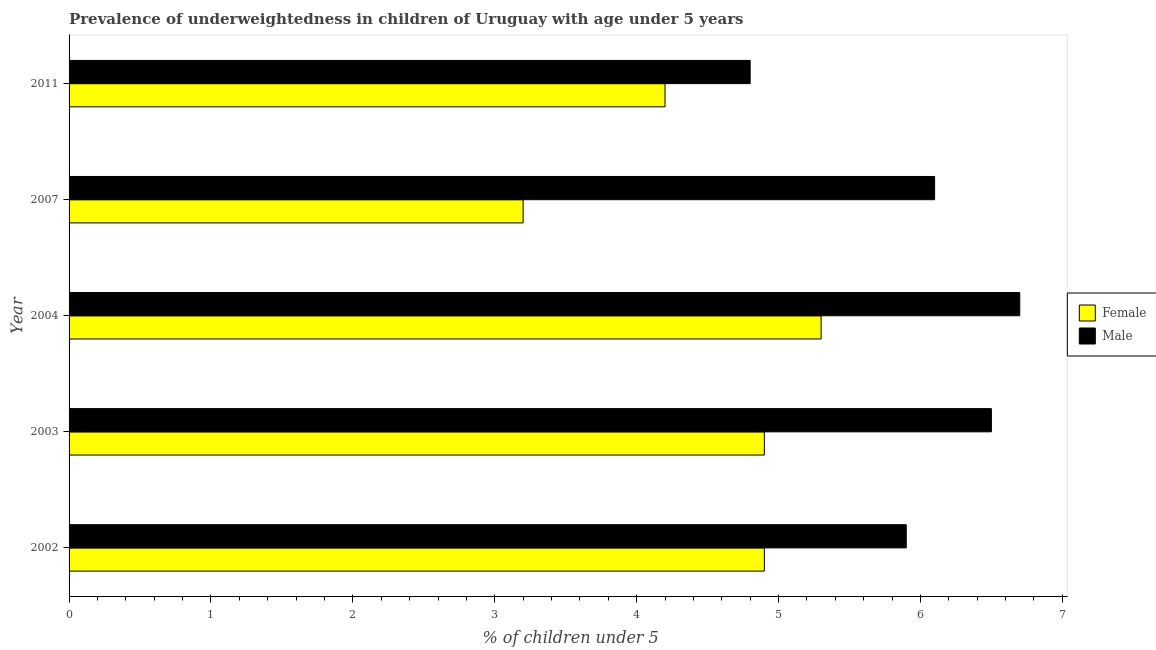How many bars are there on the 2nd tick from the bottom?
Provide a succinct answer. 2. What is the label of the 3rd group of bars from the top?
Give a very brief answer. 2004. In how many cases, is the number of bars for a given year not equal to the number of legend labels?
Your answer should be compact. 0. What is the percentage of underweighted female children in 2011?
Your answer should be compact. 4.2. Across all years, what is the maximum percentage of underweighted female children?
Offer a very short reply. 5.3. Across all years, what is the minimum percentage of underweighted female children?
Your answer should be compact. 3.2. In which year was the percentage of underweighted female children maximum?
Provide a short and direct response. 2004. What is the total percentage of underweighted male children in the graph?
Offer a terse response. 30. What is the difference between the percentage of underweighted female children in 2002 and the percentage of underweighted male children in 2004?
Give a very brief answer. -1.8. In how many years, is the percentage of underweighted male children greater than 6.8 %?
Offer a terse response. 0. Is the percentage of underweighted female children in 2002 less than that in 2007?
Make the answer very short. No. Is the difference between the percentage of underweighted male children in 2003 and 2004 greater than the difference between the percentage of underweighted female children in 2003 and 2004?
Provide a short and direct response. Yes. In how many years, is the percentage of underweighted female children greater than the average percentage of underweighted female children taken over all years?
Give a very brief answer. 3. What does the 1st bar from the bottom in 2002 represents?
Give a very brief answer. Female. How many years are there in the graph?
Keep it short and to the point. 5. Does the graph contain grids?
Your answer should be compact. No. Where does the legend appear in the graph?
Provide a succinct answer. Center right. What is the title of the graph?
Provide a short and direct response. Prevalence of underweightedness in children of Uruguay with age under 5 years. Does "Electricity and heat production" appear as one of the legend labels in the graph?
Make the answer very short. No. What is the label or title of the X-axis?
Give a very brief answer.  % of children under 5. What is the  % of children under 5 in Female in 2002?
Offer a terse response. 4.9. What is the  % of children under 5 in Male in 2002?
Keep it short and to the point. 5.9. What is the  % of children under 5 in Female in 2003?
Your response must be concise. 4.9. What is the  % of children under 5 of Male in 2003?
Offer a terse response. 6.5. What is the  % of children under 5 in Female in 2004?
Make the answer very short. 5.3. What is the  % of children under 5 of Male in 2004?
Provide a succinct answer. 6.7. What is the  % of children under 5 of Female in 2007?
Provide a succinct answer. 3.2. What is the  % of children under 5 of Male in 2007?
Offer a terse response. 6.1. What is the  % of children under 5 of Female in 2011?
Make the answer very short. 4.2. What is the  % of children under 5 of Male in 2011?
Offer a very short reply. 4.8. Across all years, what is the maximum  % of children under 5 of Female?
Offer a very short reply. 5.3. Across all years, what is the maximum  % of children under 5 in Male?
Provide a succinct answer. 6.7. Across all years, what is the minimum  % of children under 5 of Female?
Provide a short and direct response. 3.2. Across all years, what is the minimum  % of children under 5 in Male?
Make the answer very short. 4.8. What is the total  % of children under 5 of Female in the graph?
Keep it short and to the point. 22.5. What is the total  % of children under 5 of Male in the graph?
Your answer should be compact. 30. What is the difference between the  % of children under 5 of Female in 2002 and that in 2004?
Provide a succinct answer. -0.4. What is the difference between the  % of children under 5 in Male in 2002 and that in 2004?
Ensure brevity in your answer.  -0.8. What is the difference between the  % of children under 5 in Male in 2002 and that in 2007?
Your answer should be very brief. -0.2. What is the difference between the  % of children under 5 in Female in 2003 and that in 2007?
Your response must be concise. 1.7. What is the difference between the  % of children under 5 in Female in 2004 and that in 2007?
Provide a succinct answer. 2.1. What is the difference between the  % of children under 5 of Male in 2004 and that in 2007?
Provide a succinct answer. 0.6. What is the difference between the  % of children under 5 in Female in 2004 and that in 2011?
Give a very brief answer. 1.1. What is the difference between the  % of children under 5 in Male in 2004 and that in 2011?
Offer a terse response. 1.9. What is the difference between the  % of children under 5 of Male in 2007 and that in 2011?
Provide a short and direct response. 1.3. What is the difference between the  % of children under 5 of Female in 2002 and the  % of children under 5 of Male in 2011?
Provide a short and direct response. 0.1. What is the difference between the  % of children under 5 in Female in 2003 and the  % of children under 5 in Male in 2004?
Your answer should be compact. -1.8. What is the difference between the  % of children under 5 in Female in 2003 and the  % of children under 5 in Male in 2007?
Keep it short and to the point. -1.2. What is the difference between the  % of children under 5 of Female in 2003 and the  % of children under 5 of Male in 2011?
Make the answer very short. 0.1. In the year 2002, what is the difference between the  % of children under 5 in Female and  % of children under 5 in Male?
Your response must be concise. -1. In the year 2004, what is the difference between the  % of children under 5 in Female and  % of children under 5 in Male?
Your answer should be compact. -1.4. In the year 2011, what is the difference between the  % of children under 5 in Female and  % of children under 5 in Male?
Your response must be concise. -0.6. What is the ratio of the  % of children under 5 of Male in 2002 to that in 2003?
Your answer should be compact. 0.91. What is the ratio of the  % of children under 5 of Female in 2002 to that in 2004?
Offer a terse response. 0.92. What is the ratio of the  % of children under 5 in Male in 2002 to that in 2004?
Provide a short and direct response. 0.88. What is the ratio of the  % of children under 5 in Female in 2002 to that in 2007?
Your answer should be very brief. 1.53. What is the ratio of the  % of children under 5 in Male in 2002 to that in 2007?
Keep it short and to the point. 0.97. What is the ratio of the  % of children under 5 of Female in 2002 to that in 2011?
Offer a very short reply. 1.17. What is the ratio of the  % of children under 5 of Male in 2002 to that in 2011?
Ensure brevity in your answer.  1.23. What is the ratio of the  % of children under 5 of Female in 2003 to that in 2004?
Make the answer very short. 0.92. What is the ratio of the  % of children under 5 of Male in 2003 to that in 2004?
Provide a short and direct response. 0.97. What is the ratio of the  % of children under 5 of Female in 2003 to that in 2007?
Provide a short and direct response. 1.53. What is the ratio of the  % of children under 5 of Male in 2003 to that in 2007?
Provide a short and direct response. 1.07. What is the ratio of the  % of children under 5 in Female in 2003 to that in 2011?
Your response must be concise. 1.17. What is the ratio of the  % of children under 5 of Male in 2003 to that in 2011?
Ensure brevity in your answer.  1.35. What is the ratio of the  % of children under 5 of Female in 2004 to that in 2007?
Ensure brevity in your answer.  1.66. What is the ratio of the  % of children under 5 in Male in 2004 to that in 2007?
Your response must be concise. 1.1. What is the ratio of the  % of children under 5 of Female in 2004 to that in 2011?
Ensure brevity in your answer.  1.26. What is the ratio of the  % of children under 5 in Male in 2004 to that in 2011?
Your response must be concise. 1.4. What is the ratio of the  % of children under 5 of Female in 2007 to that in 2011?
Offer a terse response. 0.76. What is the ratio of the  % of children under 5 in Male in 2007 to that in 2011?
Your answer should be very brief. 1.27. What is the difference between the highest and the second highest  % of children under 5 of Female?
Your answer should be compact. 0.4. What is the difference between the highest and the second highest  % of children under 5 in Male?
Offer a very short reply. 0.2. What is the difference between the highest and the lowest  % of children under 5 in Male?
Your answer should be compact. 1.9. 